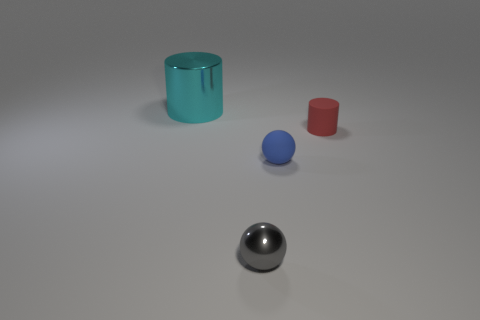Add 3 small cyan spheres. How many objects exist? 7 Add 3 red rubber things. How many red rubber things are left? 4 Add 1 tiny purple shiny cubes. How many tiny purple shiny cubes exist? 1 Subtract 0 gray cylinders. How many objects are left? 4 Subtract 1 spheres. How many spheres are left? 1 Subtract all blue cylinders. Subtract all cyan blocks. How many cylinders are left? 2 Subtract all blue blocks. How many yellow balls are left? 0 Subtract all large blue metallic objects. Subtract all gray metallic spheres. How many objects are left? 3 